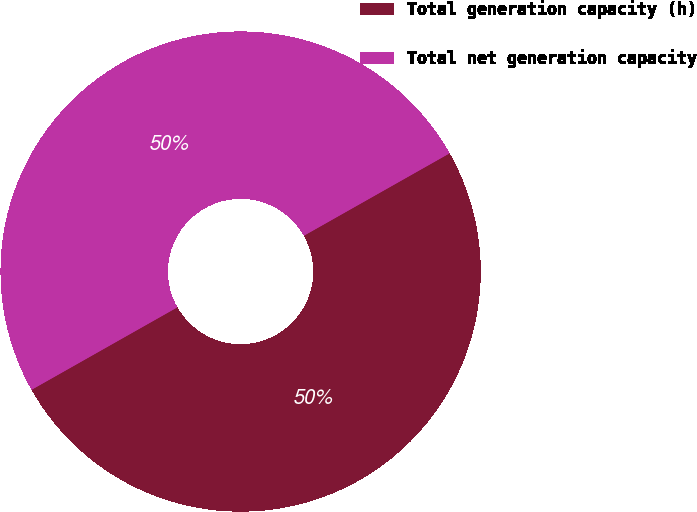Convert chart to OTSL. <chart><loc_0><loc_0><loc_500><loc_500><pie_chart><fcel>Total generation capacity (h)<fcel>Total net generation capacity<nl><fcel>50.0%<fcel>50.0%<nl></chart> 